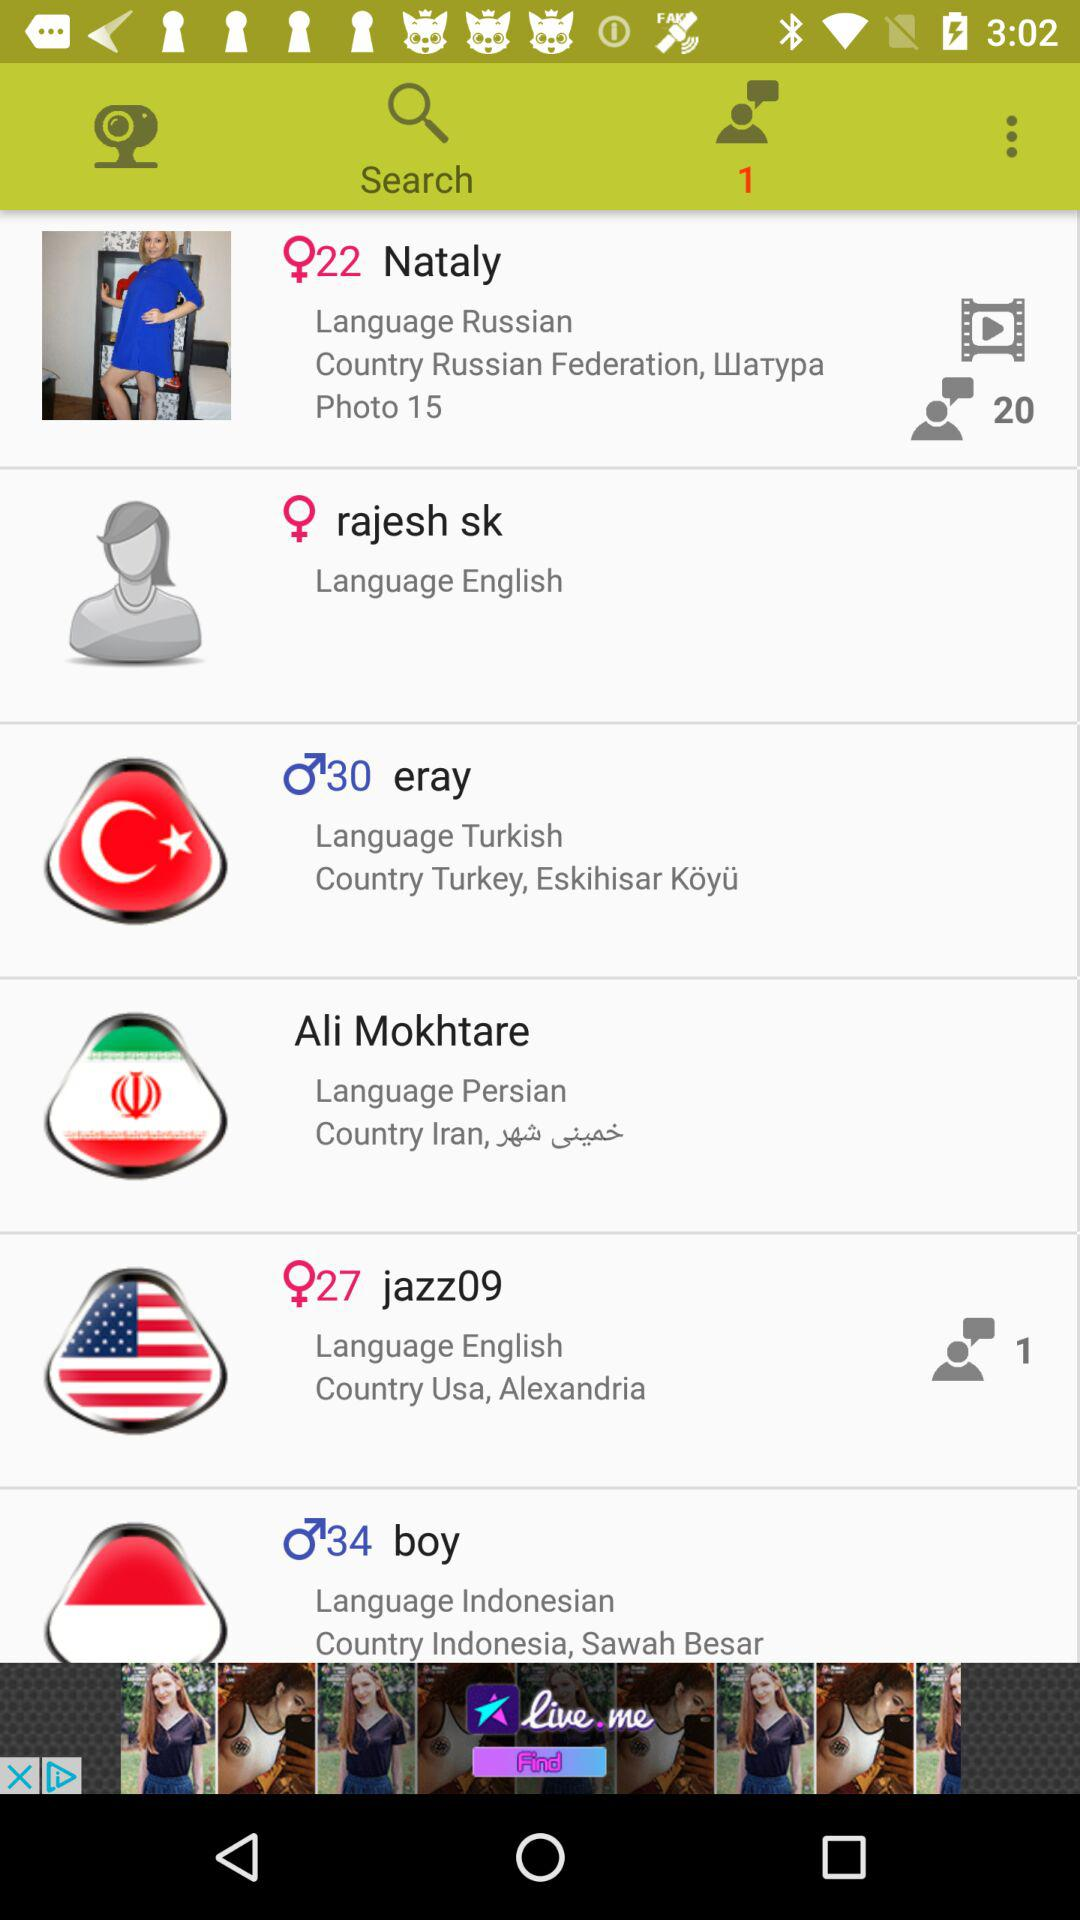Which country uses the Persian language? The country that uses the Persian language is Iran. 